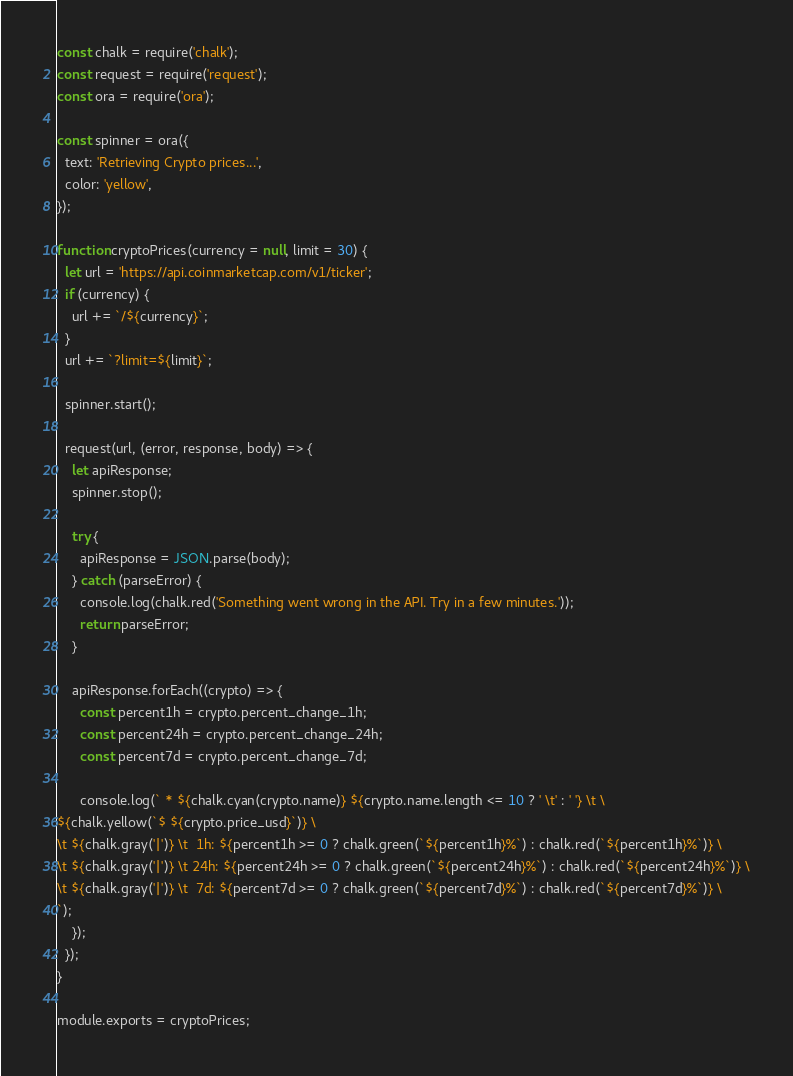<code> <loc_0><loc_0><loc_500><loc_500><_JavaScript_>const chalk = require('chalk');
const request = require('request');
const ora = require('ora');

const spinner = ora({
  text: 'Retrieving Crypto prices...',
  color: 'yellow',
});

function cryptoPrices(currency = null, limit = 30) {
  let url = 'https://api.coinmarketcap.com/v1/ticker';
  if (currency) {
    url += `/${currency}`;
  }
  url += `?limit=${limit}`;

  spinner.start();

  request(url, (error, response, body) => {
    let apiResponse;
    spinner.stop();

    try {
      apiResponse = JSON.parse(body);
    } catch (parseError) {
      console.log(chalk.red('Something went wrong in the API. Try in a few minutes.'));
      return parseError;
    }

    apiResponse.forEach((crypto) => {
      const percent1h = crypto.percent_change_1h;
      const percent24h = crypto.percent_change_24h;
      const percent7d = crypto.percent_change_7d;

      console.log(` * ${chalk.cyan(crypto.name)} ${crypto.name.length <= 10 ? ' \t' : ' '} \t \
${chalk.yellow(`$ ${crypto.price_usd}`)} \
\t ${chalk.gray('|')} \t  1h: ${percent1h >= 0 ? chalk.green(`${percent1h}%`) : chalk.red(`${percent1h}%`)} \
\t ${chalk.gray('|')} \t 24h: ${percent24h >= 0 ? chalk.green(`${percent24h}%`) : chalk.red(`${percent24h}%`)} \
\t ${chalk.gray('|')} \t  7d: ${percent7d >= 0 ? chalk.green(`${percent7d}%`) : chalk.red(`${percent7d}%`)} \
`);
    });
  });
}

module.exports = cryptoPrices;
</code> 